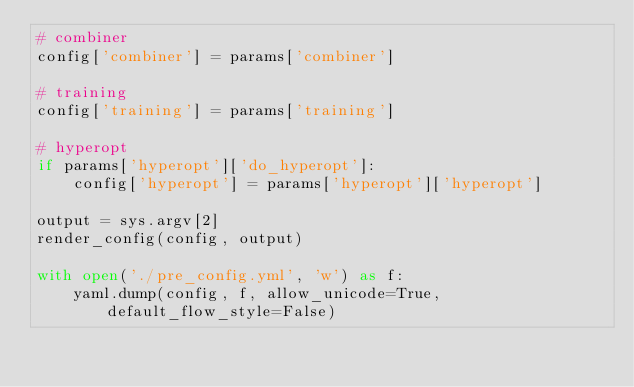Convert code to text. <code><loc_0><loc_0><loc_500><loc_500><_Python_># combiner
config['combiner'] = params['combiner']

# training
config['training'] = params['training']

# hyperopt
if params['hyperopt']['do_hyperopt']:
    config['hyperopt'] = params['hyperopt']['hyperopt']

output = sys.argv[2]
render_config(config, output)

with open('./pre_config.yml', 'w') as f:
    yaml.dump(config, f, allow_unicode=True, default_flow_style=False)</code> 